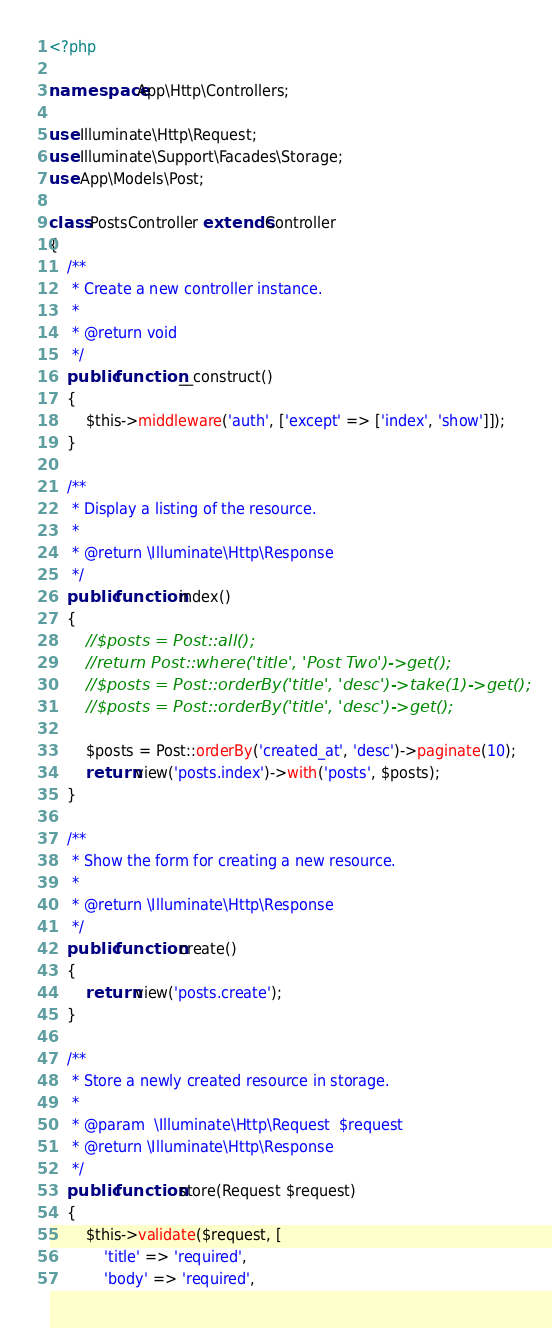<code> <loc_0><loc_0><loc_500><loc_500><_PHP_><?php

namespace App\Http\Controllers;

use Illuminate\Http\Request;
use Illuminate\Support\Facades\Storage;
use App\Models\Post;

class PostsController extends Controller
{
    /**
     * Create a new controller instance.
     *
     * @return void
     */
    public function __construct()
    {
        $this->middleware('auth', ['except' => ['index', 'show']]);
    }

    /**
     * Display a listing of the resource.
     *
     * @return \Illuminate\Http\Response
     */
    public function index()
    {
        //$posts = Post::all();
        //return Post::where('title', 'Post Two')->get(); 
        //$posts = Post::orderBy('title', 'desc')->take(1)->get();
        //$posts = Post::orderBy('title', 'desc')->get();
        
        $posts = Post::orderBy('created_at', 'desc')->paginate(10);
        return view('posts.index')->with('posts', $posts);
    }

    /**
     * Show the form for creating a new resource.
     *
     * @return \Illuminate\Http\Response
     */
    public function create()
    {
        return view('posts.create');
    }

    /**
     * Store a newly created resource in storage.
     *
     * @param  \Illuminate\Http\Request  $request
     * @return \Illuminate\Http\Response
     */
    public function store(Request $request)
    {
        $this->validate($request, [
            'title' => 'required',
            'body' => 'required',</code> 